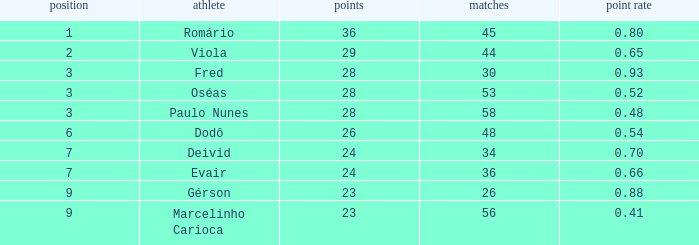How many goals have a goal ration less than 0.8 with 56 games? 1.0. 